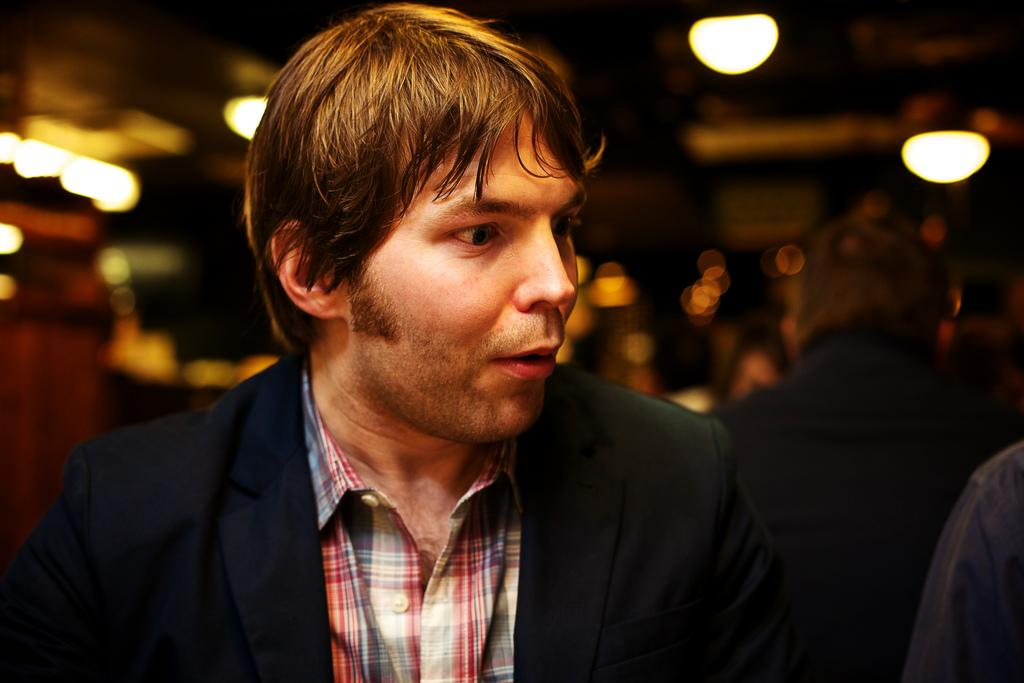What is the man in the image wearing? The man in the image is wearing a suit. Can you describe the other people in the image? There are other people in the image, but their specific appearance is not mentioned in the facts. What can be said about the background of the image? The background of the image is blurred. What can be seen in the image that might provide illumination? There are lights visible in the image. What type of disease is the man in the image suffering from? There is no information about the man's health in the image or the provided facts, so it cannot be determined if he is suffering from any disease. 